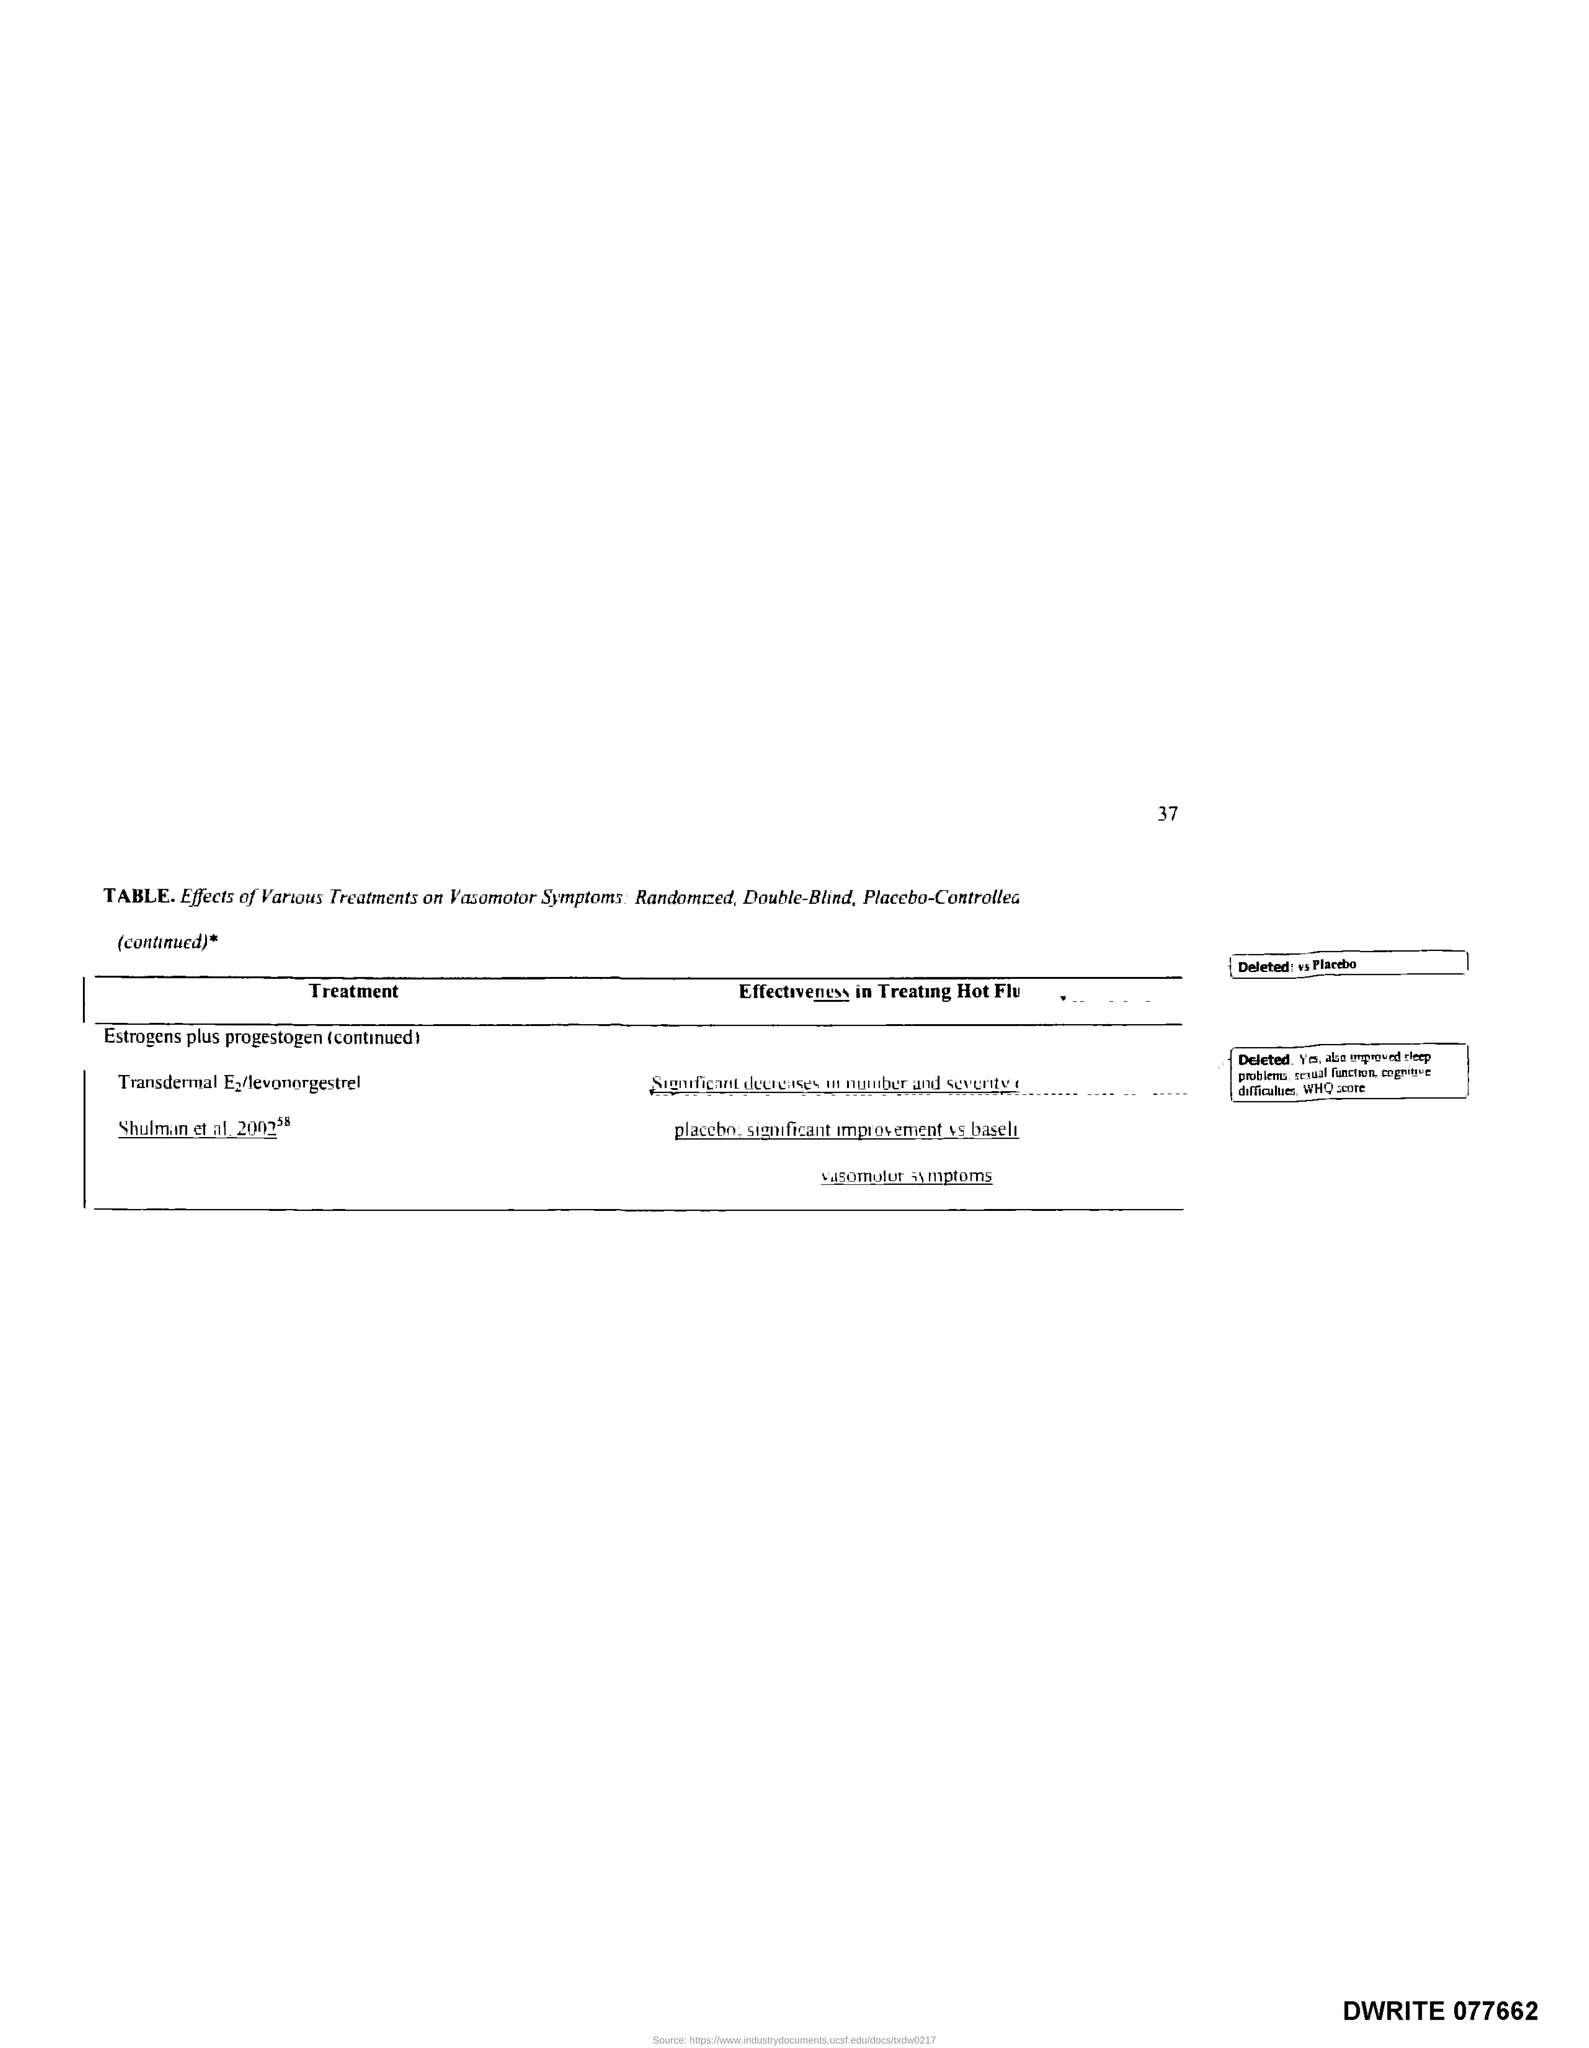Point out several critical features in this image. The page number is 37. 